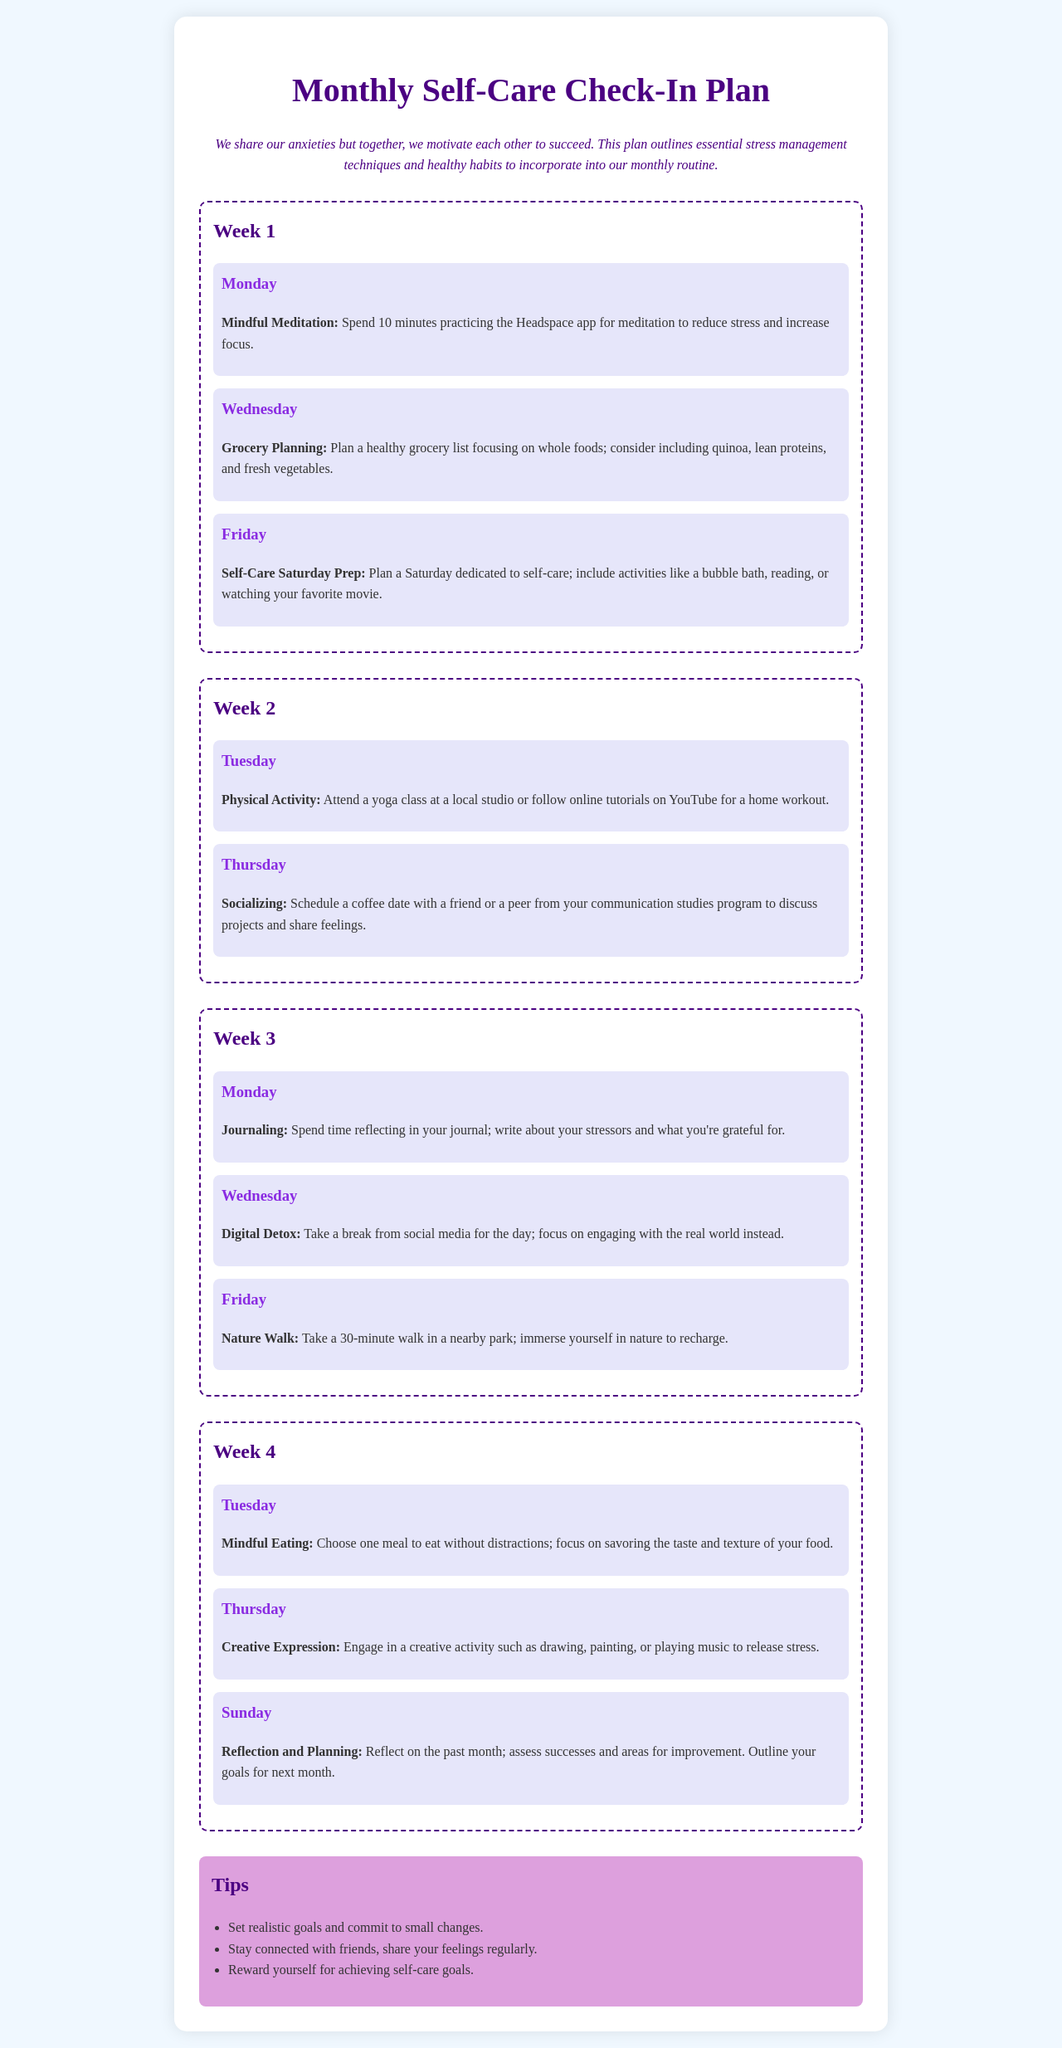What activities are planned for Week 1? Week 1 includes Mindful Meditation, Grocery Planning, and Self-Care Saturday Prep activities.
Answer: Mindful Meditation, Grocery Planning, Self-Care Saturday Prep What is the primary focus of the introduction? The introduction emphasizes the importance of motivation and shared experiences in managing anxieties.
Answer: Motivation and shared experiences How many weeks are included in the plan? The document outlines a monthly check-in plan divided into four weeks.
Answer: Four weeks On which day is the Digital Detox scheduled? Digital Detox is planned for Wednesday of Week 3.
Answer: Wednesday What self-care activity is scheduled for the last day of the month? The last self-care activity planned for Sunday is Reflection and Planning.
Answer: Reflection and Planning Which technique involves engaging creatively to release stress? Creative Expression is the technique that involves engaging in creative activities.
Answer: Creative Expression What is suggested for maintaining connections with friends? The document suggests scheduling a coffee date to share feelings and discuss projects.
Answer: Schedule a coffee date How long should the Nature Walk last? The Nature Walk should last for 30 minutes according to the plan.
Answer: 30 minutes 